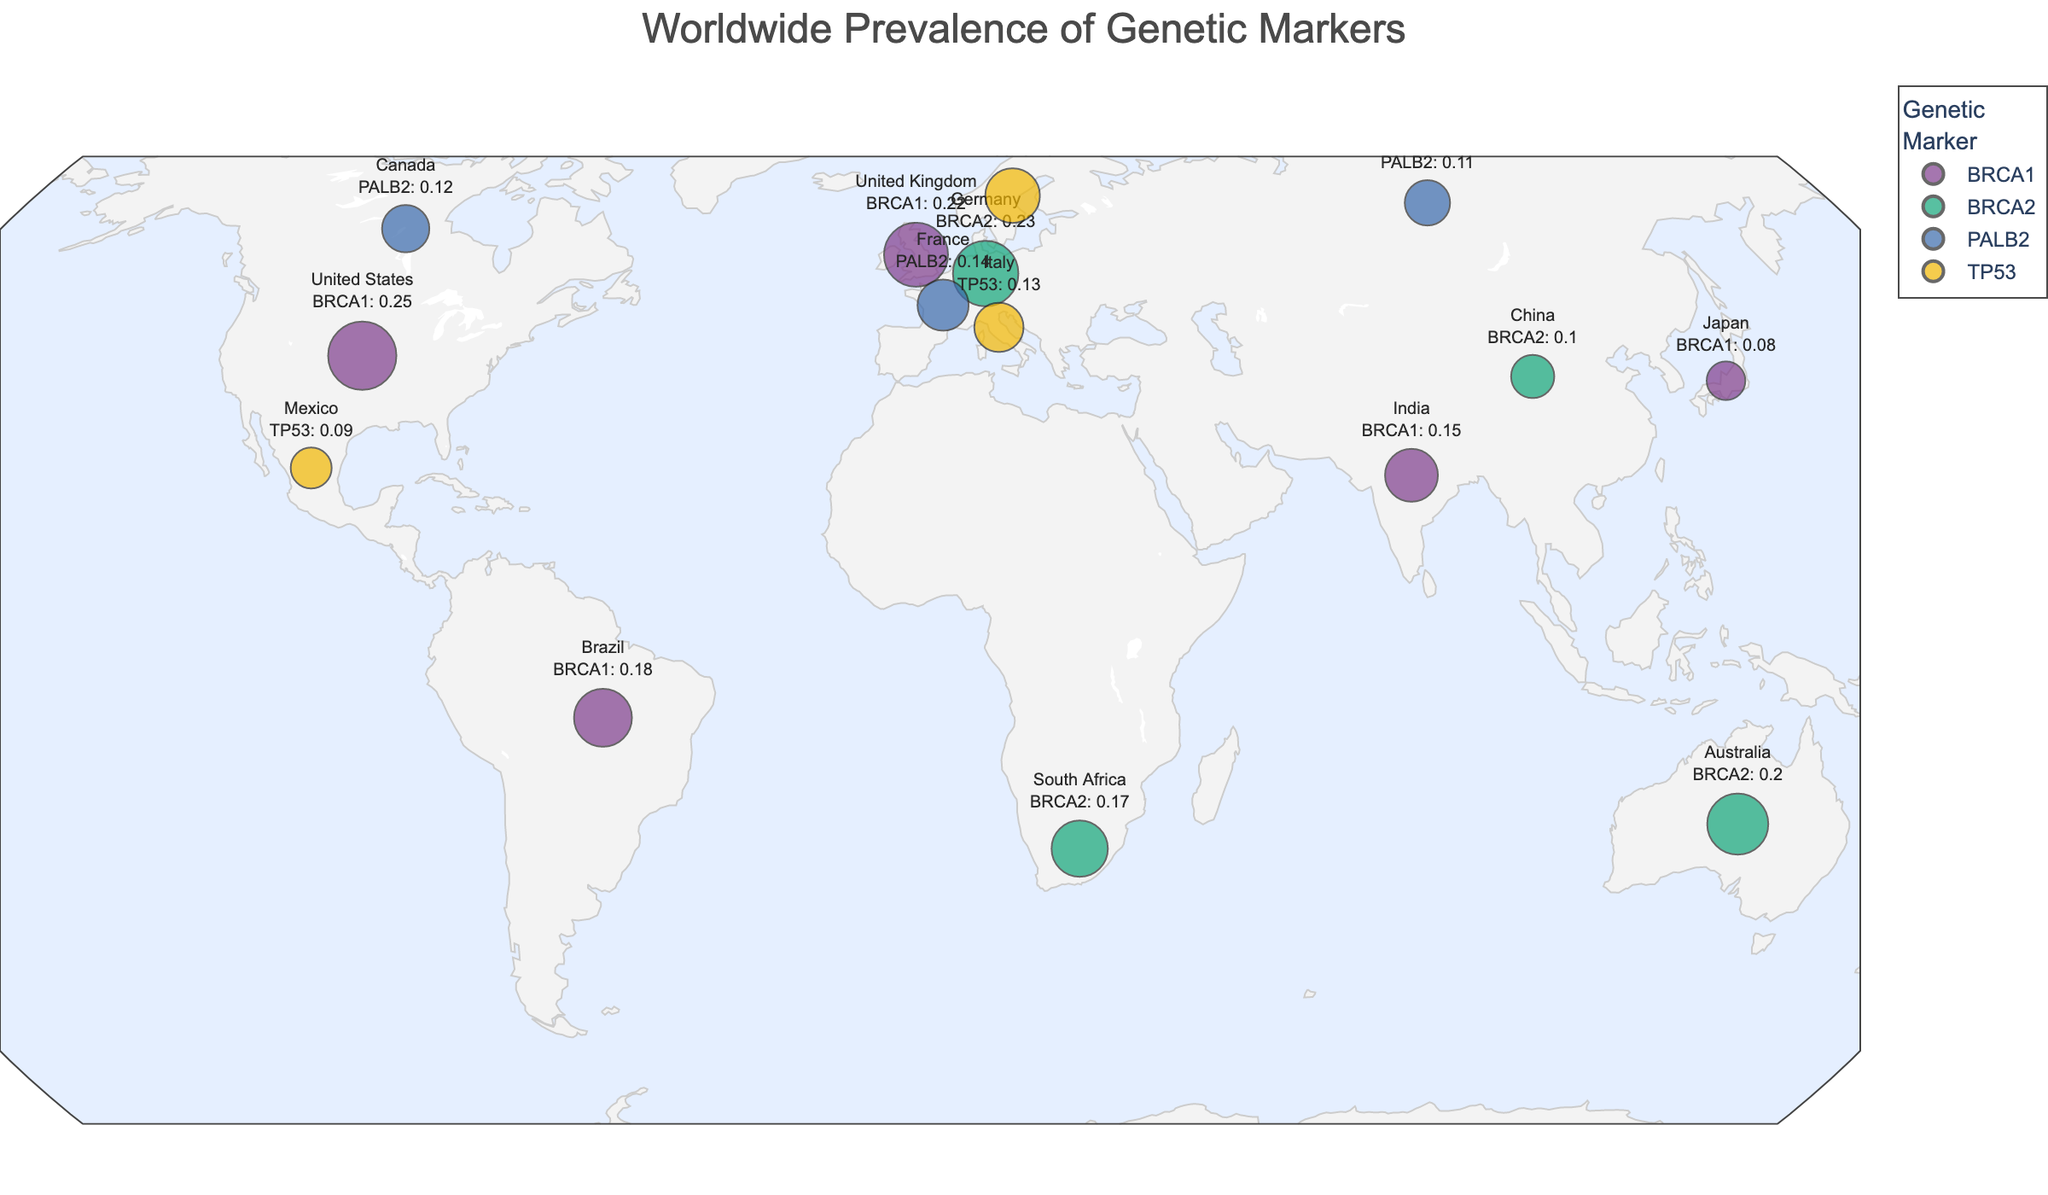What is the title of the figure? The title is located at the top of the figure, clearly stating the main topic.
Answer: Worldwide Prevalence of Genetic Markers How many countries are represented in the figure? Each data point represents a country, count the total number of distinct countries on the map.
Answer: 15 Which country has the highest prevalence of the BRCA1 genetic marker? Identify all points representing BRCA1, then find the one with the highest size.
Answer: United States What is the common feature of the colors used for different genetic markers? Look at the legend and note the distinct colors assigned to each genetic marker.
Answer: They are bright and bold Which genetic marker has the highest overall prevalence and in which country? Compare the prevalence values of all genetic markers across different countries and identify the maximum value and associated country.
Answer: BRCA1 in the United States Which countries have a prevalence of BRCA2 genetic marker greater than 0.20? Filter the data points representing BRCA2 and check their prevalence values.
Answer: Germany and Australia What is the average prevalence of the TP53 genetic marker across all countries? Add the prevalence values of TP53 for all countries and divide by the number of countries.
Answer: (0.09 + 0.13 + 0.16)/3 = 0.1267 Which genetic markers are represented in countries from both Europe and Asia? Identify the countries in Europe and Asia, then check the genetic markers they represent.
Answer: BRCA1 and BRCA2 Compare the prevalence of the PALB2 genetic marker in France and Canada. Which has a higher prevalence? Look at the prevalence values for PALB2 in France and Canada and compare them.
Answer: France How is the projection used for the geographical plot labeled in natural terms? Refer to the projection type used for the map.
Answer: Natural Earth 